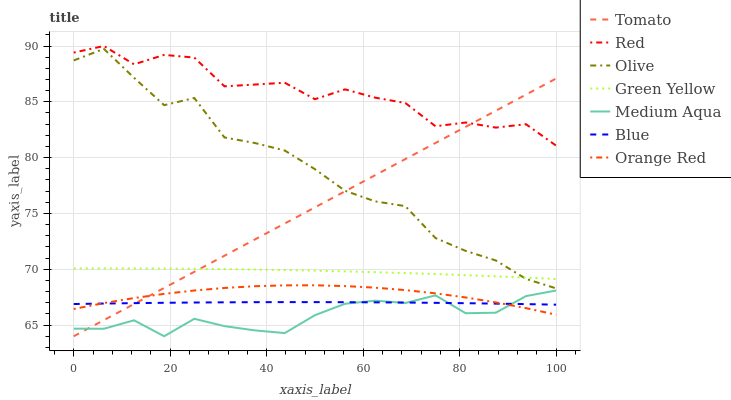Does Medium Aqua have the minimum area under the curve?
Answer yes or no. Yes. Does Red have the maximum area under the curve?
Answer yes or no. Yes. Does Blue have the minimum area under the curve?
Answer yes or no. No. Does Blue have the maximum area under the curve?
Answer yes or no. No. Is Tomato the smoothest?
Answer yes or no. Yes. Is Red the roughest?
Answer yes or no. Yes. Is Blue the smoothest?
Answer yes or no. No. Is Blue the roughest?
Answer yes or no. No. Does Tomato have the lowest value?
Answer yes or no. Yes. Does Blue have the lowest value?
Answer yes or no. No. Does Red have the highest value?
Answer yes or no. Yes. Does Medium Aqua have the highest value?
Answer yes or no. No. Is Medium Aqua less than Green Yellow?
Answer yes or no. Yes. Is Olive greater than Blue?
Answer yes or no. Yes. Does Orange Red intersect Medium Aqua?
Answer yes or no. Yes. Is Orange Red less than Medium Aqua?
Answer yes or no. No. Is Orange Red greater than Medium Aqua?
Answer yes or no. No. Does Medium Aqua intersect Green Yellow?
Answer yes or no. No. 